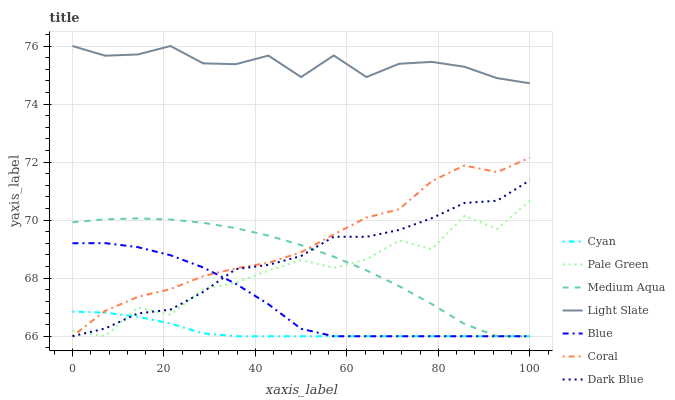Does Cyan have the minimum area under the curve?
Answer yes or no. Yes. Does Light Slate have the maximum area under the curve?
Answer yes or no. Yes. Does Coral have the minimum area under the curve?
Answer yes or no. No. Does Coral have the maximum area under the curve?
Answer yes or no. No. Is Cyan the smoothest?
Answer yes or no. Yes. Is Pale Green the roughest?
Answer yes or no. Yes. Is Light Slate the smoothest?
Answer yes or no. No. Is Light Slate the roughest?
Answer yes or no. No. Does Blue have the lowest value?
Answer yes or no. Yes. Does Light Slate have the lowest value?
Answer yes or no. No. Does Light Slate have the highest value?
Answer yes or no. Yes. Does Coral have the highest value?
Answer yes or no. No. Is Coral less than Light Slate?
Answer yes or no. Yes. Is Light Slate greater than Coral?
Answer yes or no. Yes. Does Dark Blue intersect Cyan?
Answer yes or no. Yes. Is Dark Blue less than Cyan?
Answer yes or no. No. Is Dark Blue greater than Cyan?
Answer yes or no. No. Does Coral intersect Light Slate?
Answer yes or no. No. 